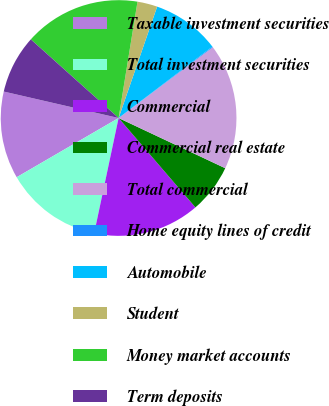<chart> <loc_0><loc_0><loc_500><loc_500><pie_chart><fcel>Taxable investment securities<fcel>Total investment securities<fcel>Commercial<fcel>Commercial real estate<fcel>Total commercial<fcel>Home equity lines of credit<fcel>Automobile<fcel>Student<fcel>Money market accounts<fcel>Term deposits<nl><fcel>11.98%<fcel>13.3%<fcel>14.62%<fcel>6.7%<fcel>17.26%<fcel>0.1%<fcel>9.34%<fcel>2.74%<fcel>15.94%<fcel>8.02%<nl></chart> 